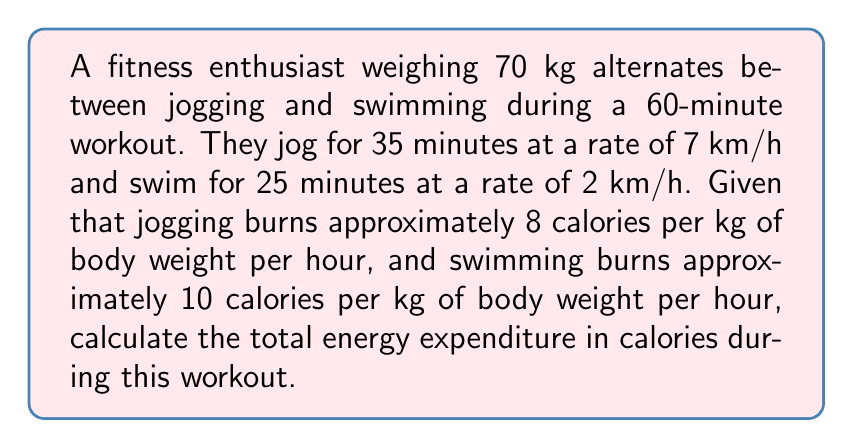Give your solution to this math problem. Let's break this problem down step-by-step:

1. Calculate the energy expenditure for jogging:
   - Time spent jogging: 35 minutes = $\frac{35}{60} = 0.5833$ hours
   - Calories burned per hour while jogging: $8 \times 70 = 560$ cal/hr
   - Energy expended jogging: $E_j = 560 \times 0.5833 = 326.67$ cal

2. Calculate the energy expenditure for swimming:
   - Time spent swimming: 25 minutes = $\frac{25}{60} = 0.4167$ hours
   - Calories burned per hour while swimming: $10 \times 70 = 700$ cal/hr
   - Energy expended swimming: $E_s = 700 \times 0.4167 = 291.67$ cal

3. Sum up the total energy expenditure:
   $E_{total} = E_j + E_s = 326.67 + 291.67 = 618.34$ cal

Therefore, the total energy expenditure during the 60-minute workout is approximately 618.34 calories.
Answer: 618.34 calories 